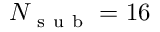<formula> <loc_0><loc_0><loc_500><loc_500>N _ { s u b } = 1 6</formula> 